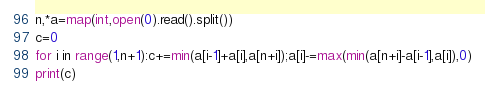Convert code to text. <code><loc_0><loc_0><loc_500><loc_500><_Python_>n,*a=map(int,open(0).read().split())
c=0
for i in range(1,n+1):c+=min(a[i-1]+a[i],a[n+i]);a[i]-=max(min(a[n+i]-a[i-1],a[i]),0)
print(c)</code> 